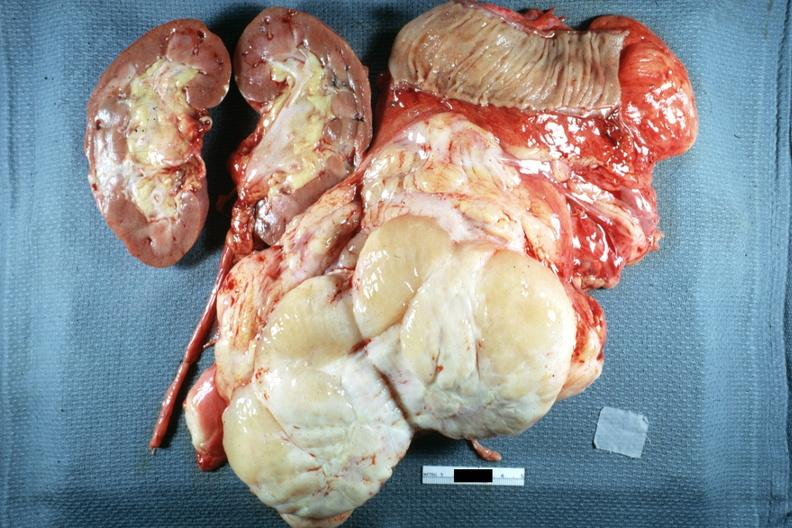does surface show typical fish flesh and yellow sarcoma?
Answer the question using a single word or phrase. Yes 